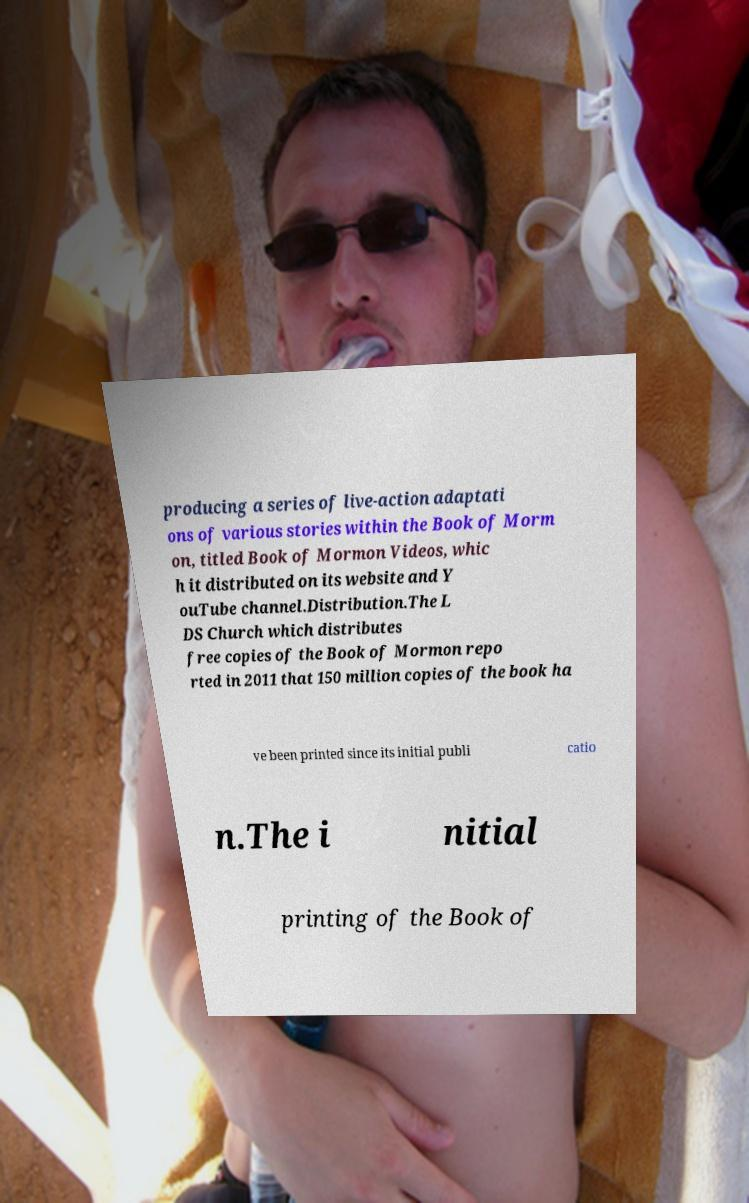For documentation purposes, I need the text within this image transcribed. Could you provide that? producing a series of live-action adaptati ons of various stories within the Book of Morm on, titled Book of Mormon Videos, whic h it distributed on its website and Y ouTube channel.Distribution.The L DS Church which distributes free copies of the Book of Mormon repo rted in 2011 that 150 million copies of the book ha ve been printed since its initial publi catio n.The i nitial printing of the Book of 